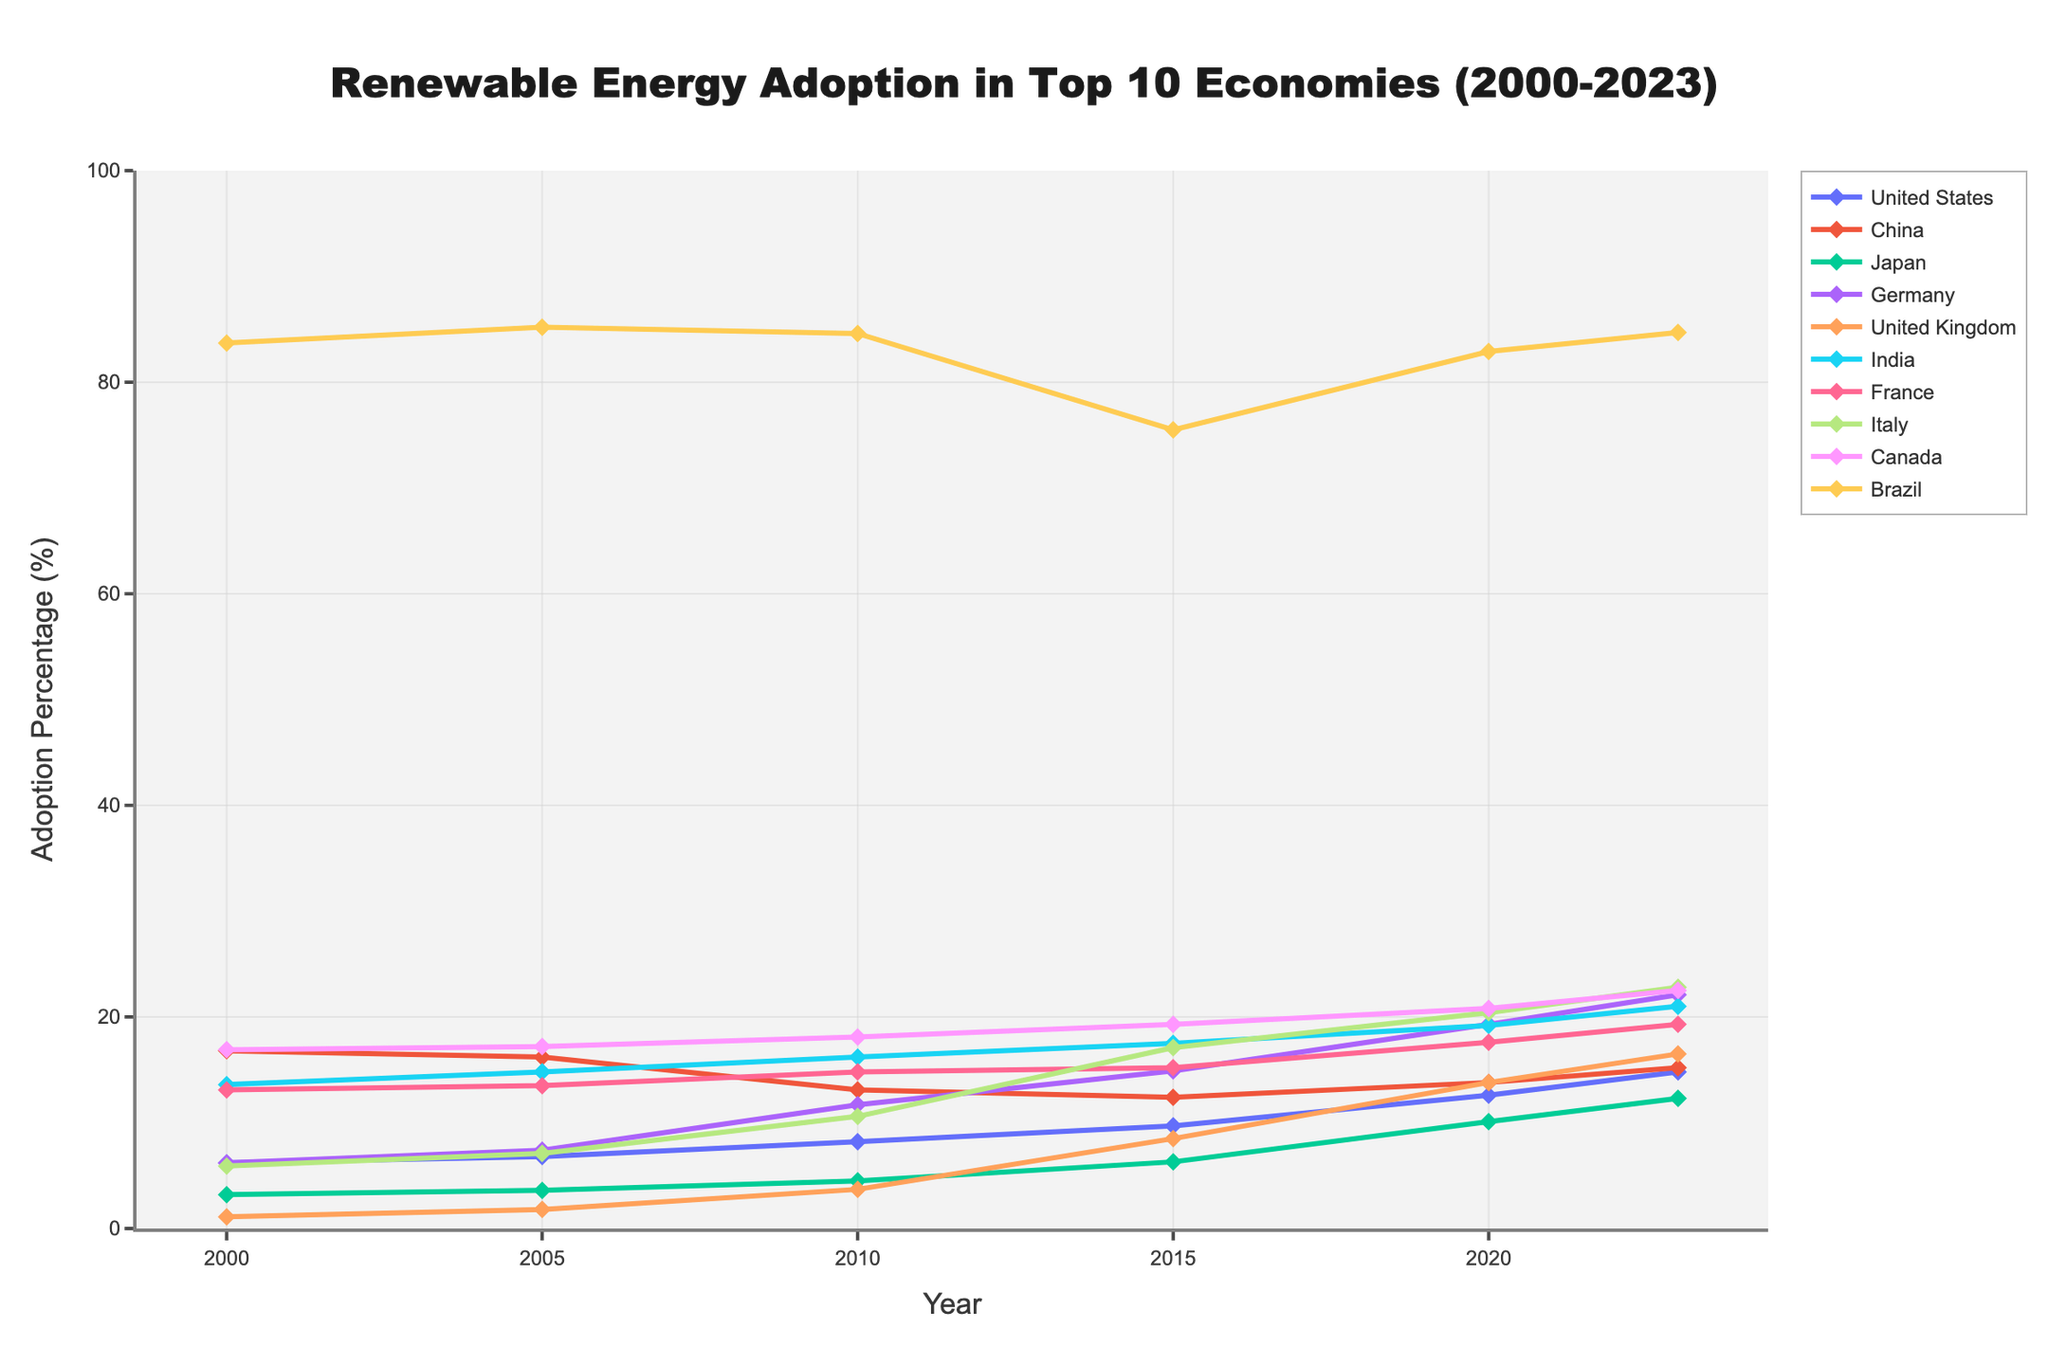What is the percentage increase in renewable energy adoption in Germany from 2000 to 2023? The value in 2000 for Germany is 6.2% and in 2023 it is 22.1%. The percentage increase is ((22.1 - 6.2) / 6.2) * 100 = 256.45%
Answer: 256.45% Which country has the highest renewable energy adoption in 2023? By looking at the endpoints of the lines at 2023, Brazil has the highest adoption percentage at 84.7%
Answer: Brazil Between which consecutive years did the United Kingdom see the greatest increase in renewable energy adoption? We need to calculate the differences between consecutive years: 2005-2000 is 1.8-1.1=0.7, 2010-2005 is 3.7-1.8=1.9, 2015-2010 is 8.5-3.7=4.8, 2020-2015 is 13.8-8.5=5.3, 2023-2020 is 16.5-13.8=2.7. The greatest increase is 2015 to 2020 with 5.3%
Answer: 2015-2020 What was the average renewable energy adoption percentage for India from 2010 to 2023? The values for India are 16.2 (2010), 17.5 (2015), 19.2 (2020), and 21.0 (2023). Sum these values: 16.2 + 17.5 + 19.2 + 21.0 = 73.9, divide by the number of data points: 73.9 / 4 = 18.475
Answer: 18.475 Is the renewable energy adoption percentage of China higher or lower than that of France in 2023? Refer to the value for China in 2023 (15.2%) and for France in 2023 (19.3%). China's adoption percentage is lower
Answer: Lower What is the trend in renewable energy adoption for Brazil from 2010 to 2015? Observe the line for Brazil from 2010 to 2015, it decreases from 84.6% to 75.5%
Answer: Decreasing How many countries had a renewable energy adoption percentage of over 20% in 2023? Examine the endpoints of each line in 2023. Germany (22.1), India (21.0), France (19.3), Italy (22.8), Canada (22.5), and Brazil (84.7) each surpassed 20%
Answer: 5 countries Which country had the smallest increase in renewable energy adoption from 2000 to 2023? Calculate the increase for each country and identify the smallest increment. United States (14.8-6.2=8.6), China (15.2-16.8=-1.6), Japan (12.3-3.2=9.1), Germany (22.1-6.2=15.9), United Kingdom (16.5-1.1=15.4), India (21-13.6=7.4), France (19.3-13.1=6.2), Italy (22.8-5.9=16.9), Canada (22.5-16.9=5.6), Brazil (84.7-83.7=1.0). China's value is negative indicating a decrease but based on increase Brazil's steady value suggests smallest increase as 1.0%
Answer: Brazil 